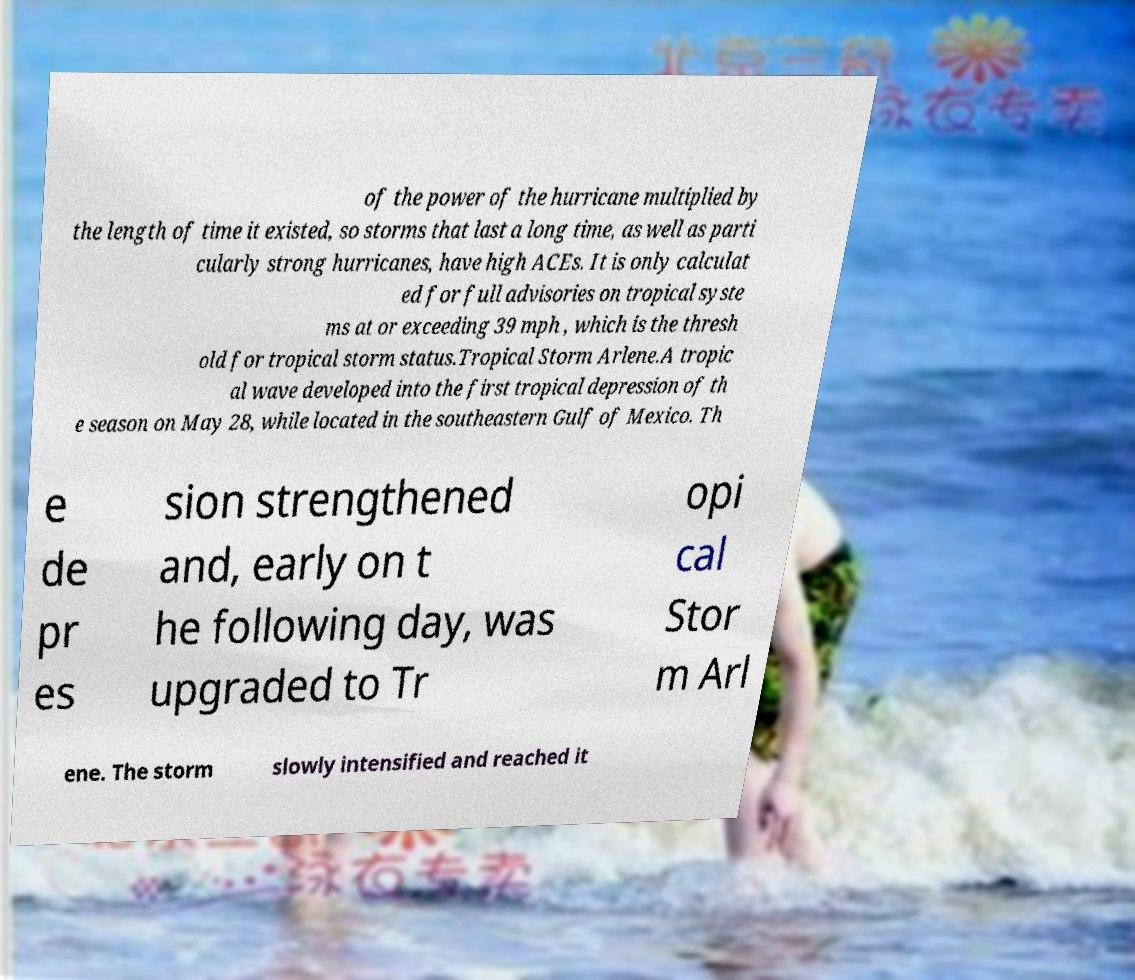Could you assist in decoding the text presented in this image and type it out clearly? of the power of the hurricane multiplied by the length of time it existed, so storms that last a long time, as well as parti cularly strong hurricanes, have high ACEs. It is only calculat ed for full advisories on tropical syste ms at or exceeding 39 mph , which is the thresh old for tropical storm status.Tropical Storm Arlene.A tropic al wave developed into the first tropical depression of th e season on May 28, while located in the southeastern Gulf of Mexico. Th e de pr es sion strengthened and, early on t he following day, was upgraded to Tr opi cal Stor m Arl ene. The storm slowly intensified and reached it 